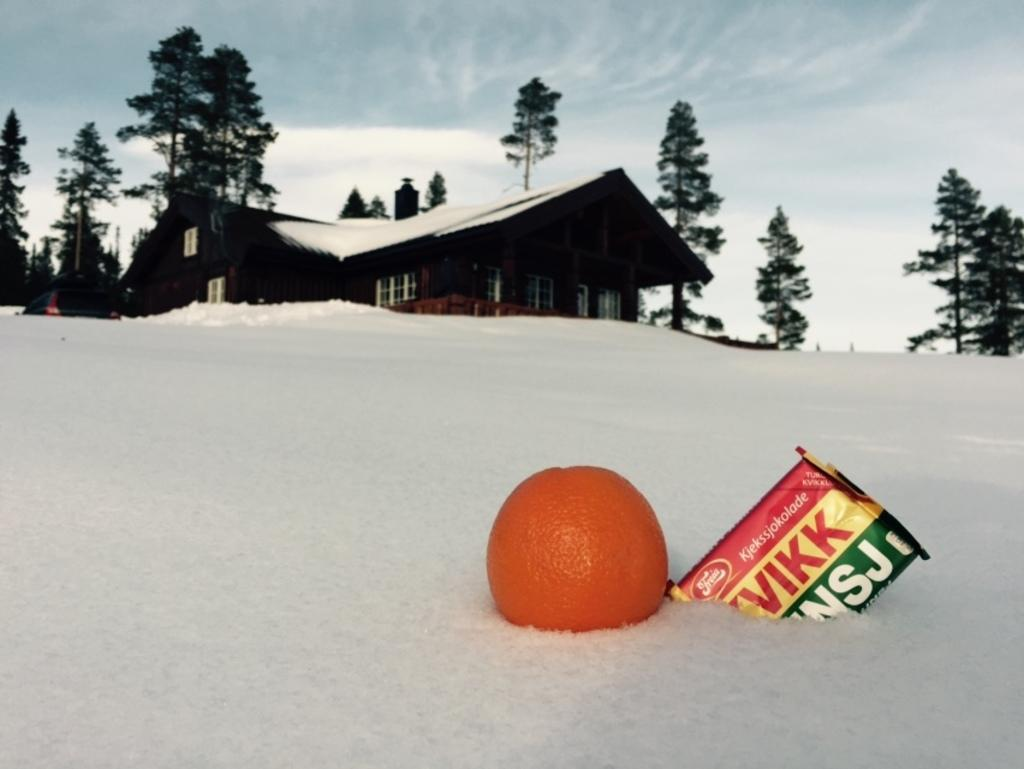What type of structures can be seen in the image? There are houses in the image. What is covering the ground in the image? The ground is covered with snow. What else can be seen in the image besides houses and snow? There are objects, a vehicle, trees, and the sky visible in the image. What nation is responsible for promoting peace in the image? There is no reference to a nation or peace promotion in the image. What is the tendency of the trees in the image? The image does not provide information about the trees' tendencies. 